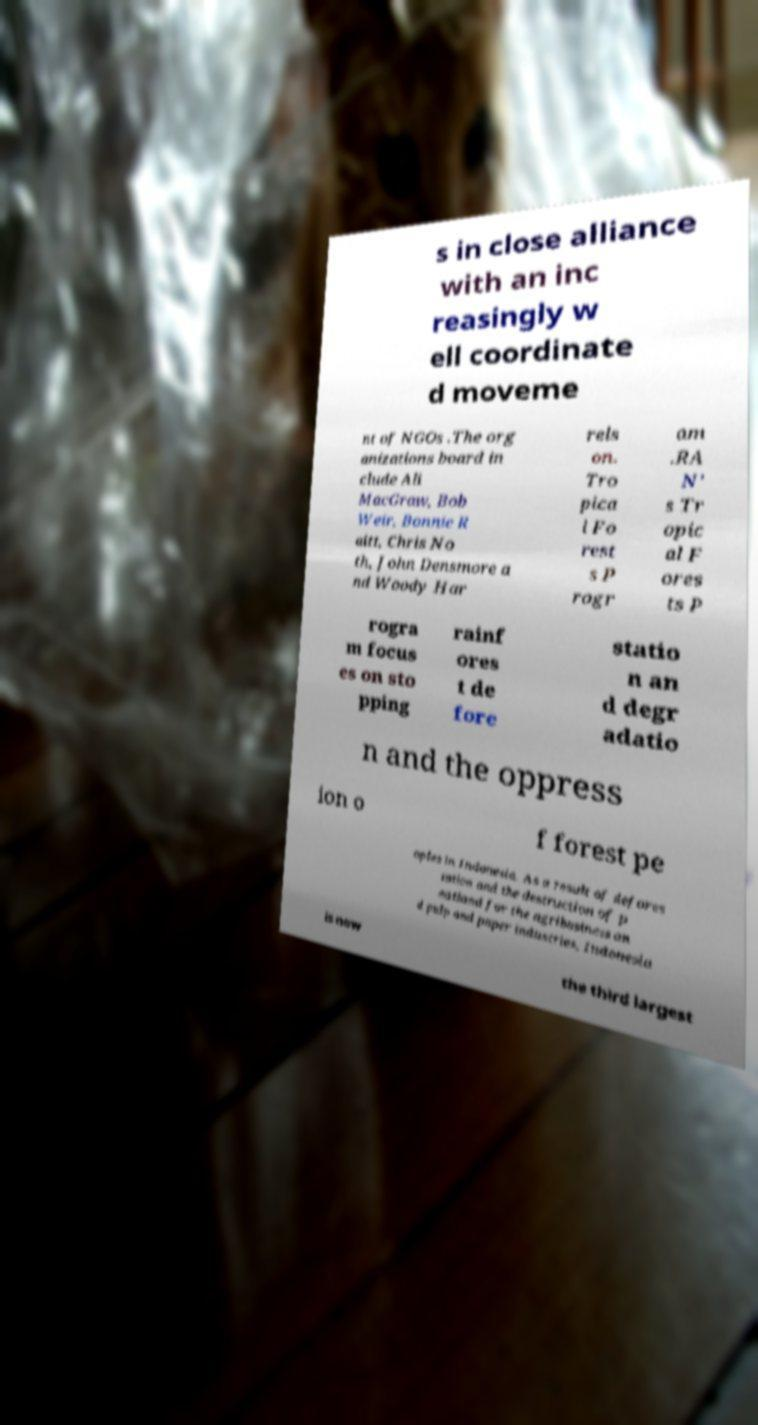Can you accurately transcribe the text from the provided image for me? s in close alliance with an inc reasingly w ell coordinate d moveme nt of NGOs .The org anizations board in clude Ali MacGraw, Bob Weir, Bonnie R aitt, Chris No th, John Densmore a nd Woody Har rels on. Tro pica l Fo rest s P rogr am .RA N’ s Tr opic al F ores ts P rogra m focus es on sto pping rainf ores t de fore statio n an d degr adatio n and the oppress ion o f forest pe oples in Indonesia. As a result of defores tation and the destruction of p eatland for the agribusiness an d pulp and paper industries, Indonesia is now the third largest 